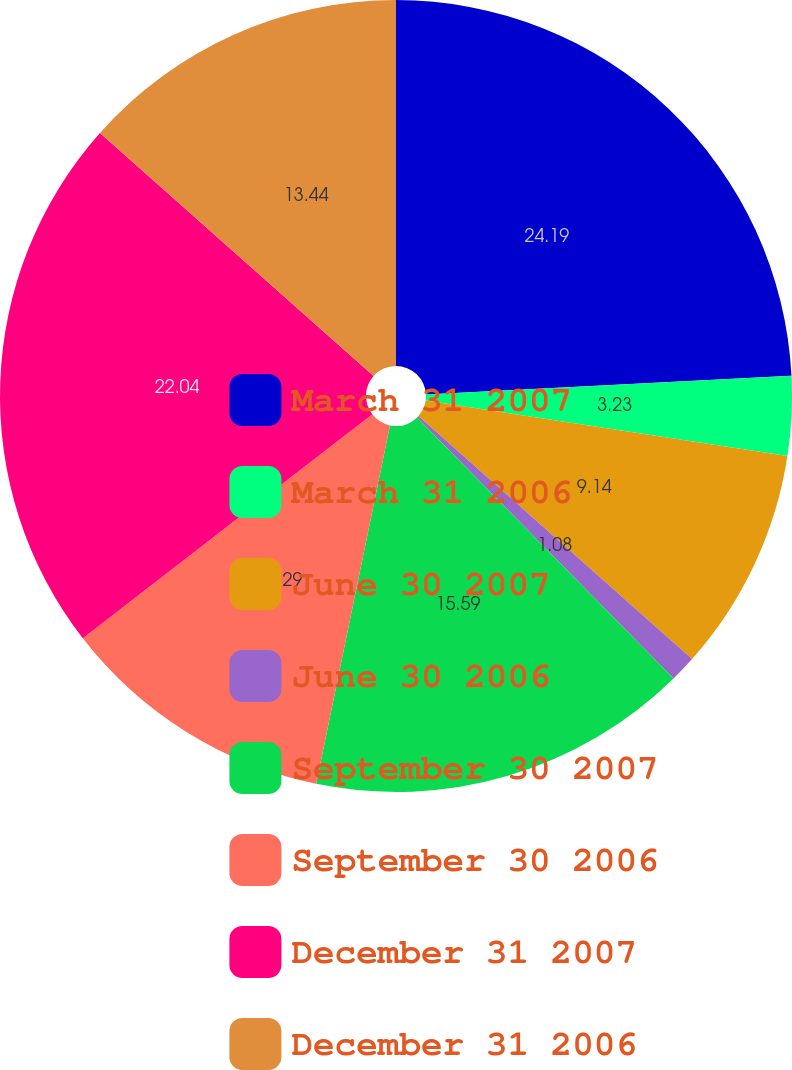Convert chart to OTSL. <chart><loc_0><loc_0><loc_500><loc_500><pie_chart><fcel>March 31 2007<fcel>March 31 2006<fcel>June 30 2007<fcel>June 30 2006<fcel>September 30 2007<fcel>September 30 2006<fcel>December 31 2007<fcel>December 31 2006<nl><fcel>24.19%<fcel>3.23%<fcel>9.14%<fcel>1.08%<fcel>15.59%<fcel>11.29%<fcel>22.04%<fcel>13.44%<nl></chart> 